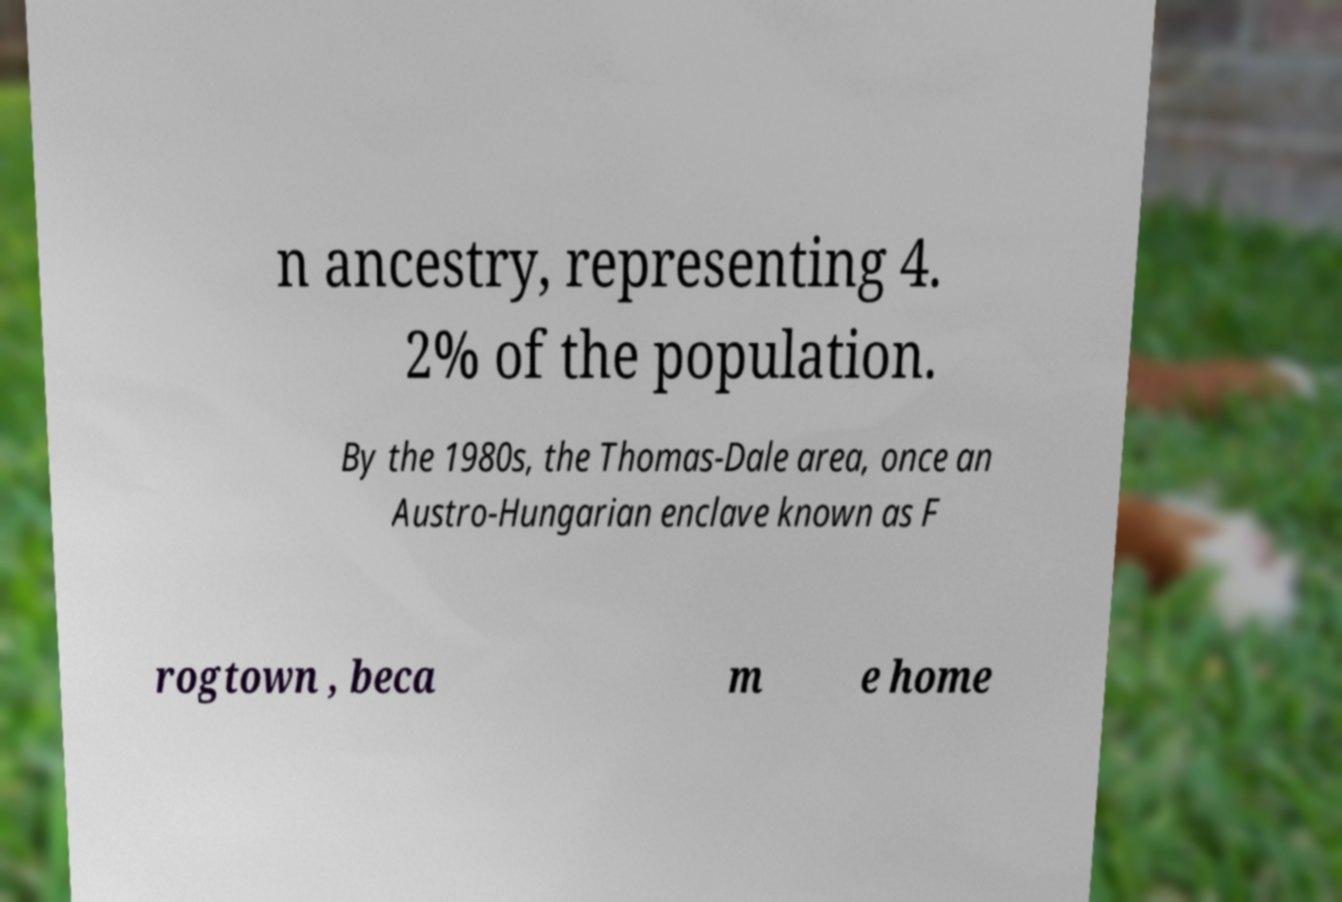Please read and relay the text visible in this image. What does it say? n ancestry, representing 4. 2% of the population. By the 1980s, the Thomas-Dale area, once an Austro-Hungarian enclave known as F rogtown , beca m e home 